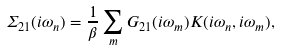<formula> <loc_0><loc_0><loc_500><loc_500>\Sigma _ { 2 1 } ( i \omega _ { n } ) = \frac { 1 } { \beta } \sum _ { m } G _ { 2 1 } ( i \omega _ { m } ) K ( i \omega _ { n } , i \omega _ { m } ) ,</formula> 